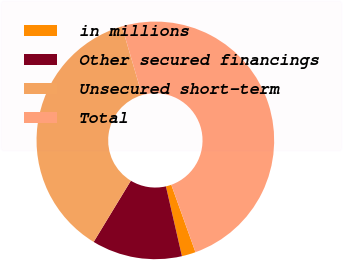<chart> <loc_0><loc_0><loc_500><loc_500><pie_chart><fcel>in millions<fcel>Other secured financings<fcel>Unsecured short-term<fcel>Total<nl><fcel>1.89%<fcel>12.28%<fcel>36.77%<fcel>49.06%<nl></chart> 